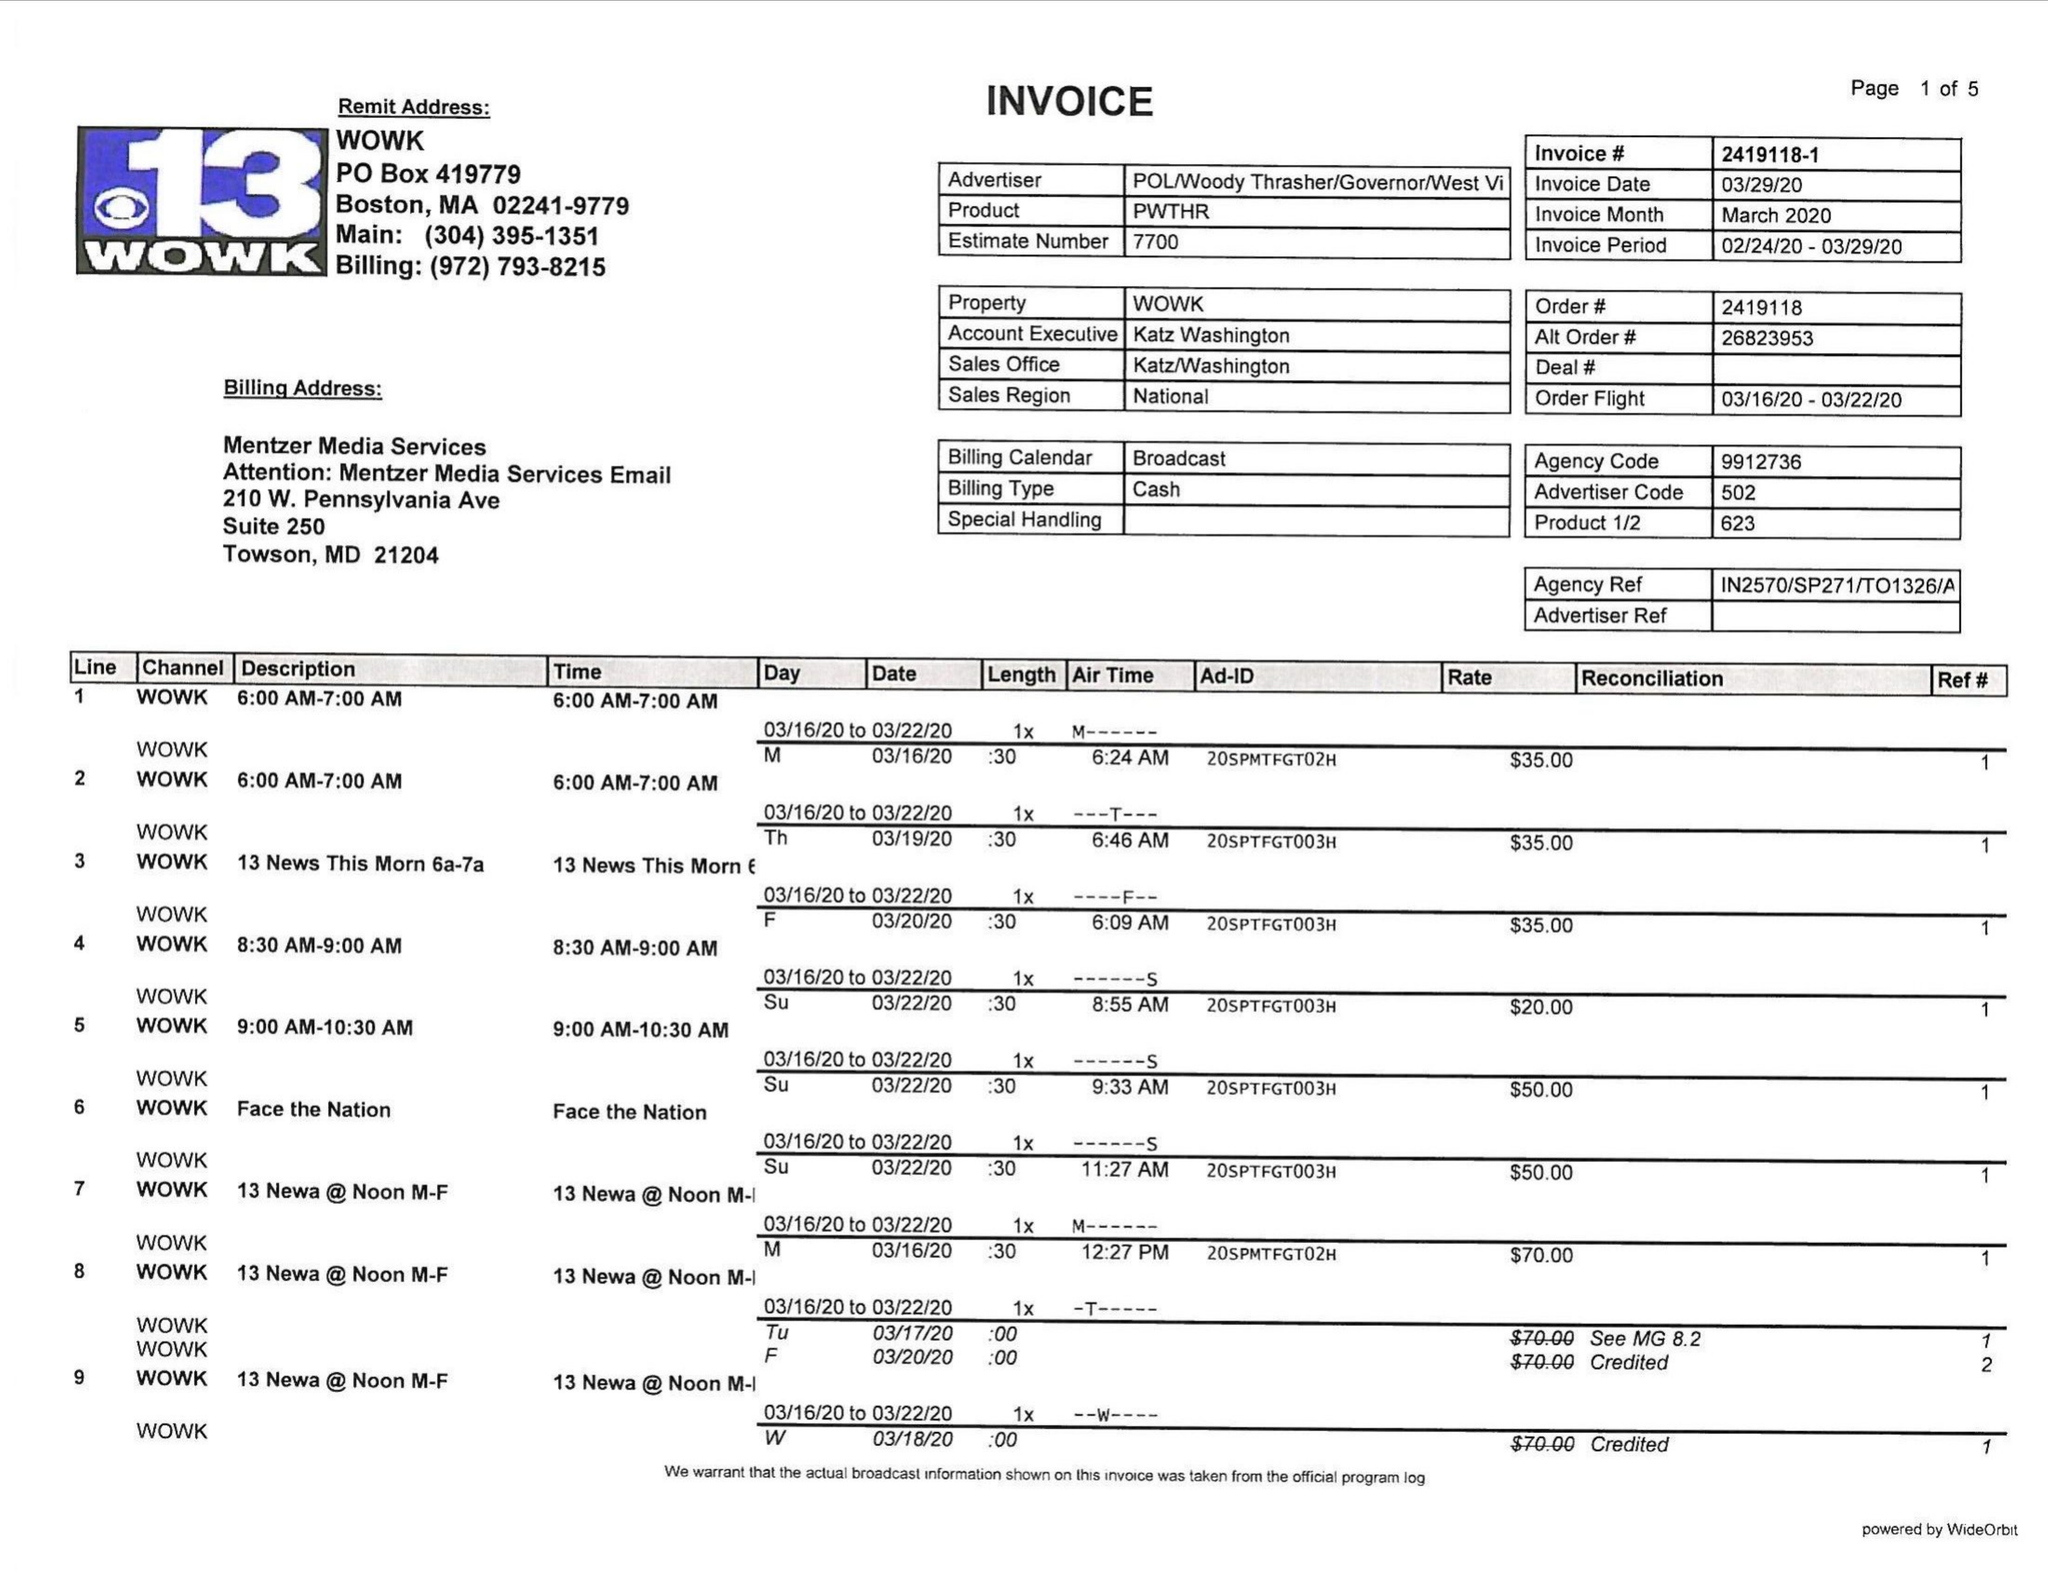What is the value for the contract_num?
Answer the question using a single word or phrase. 2419118 